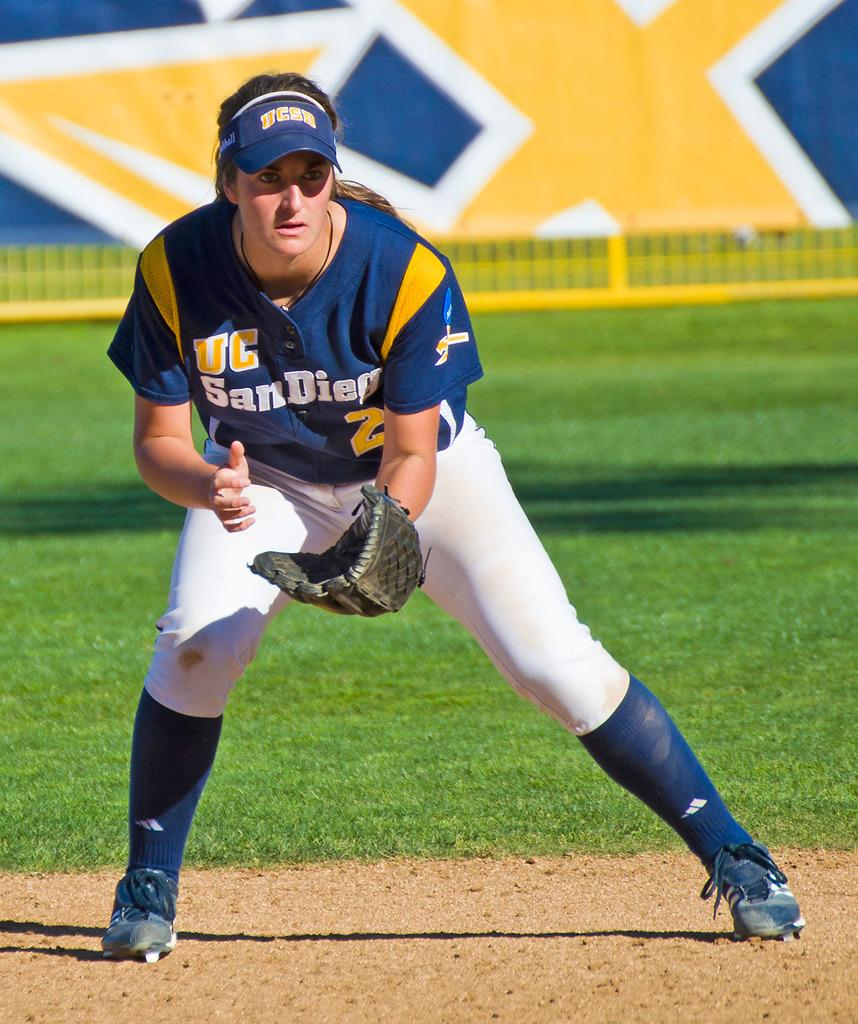<image>
Summarize the visual content of the image. a player that is wearing a San Diego jersey on the field 